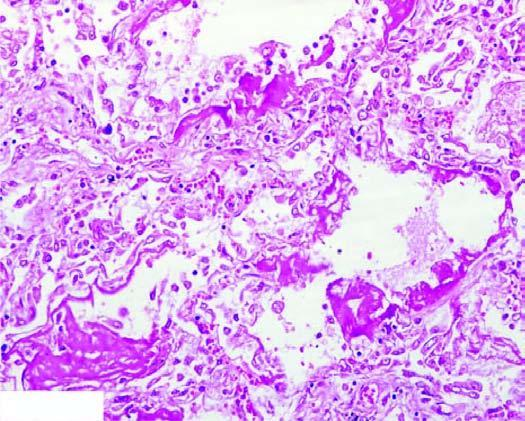re there alternate areas of collapsed and dilated alveolar spaces, many of which are lined by eosinophilic hyaline membranes?
Answer the question using a single word or phrase. Yes 